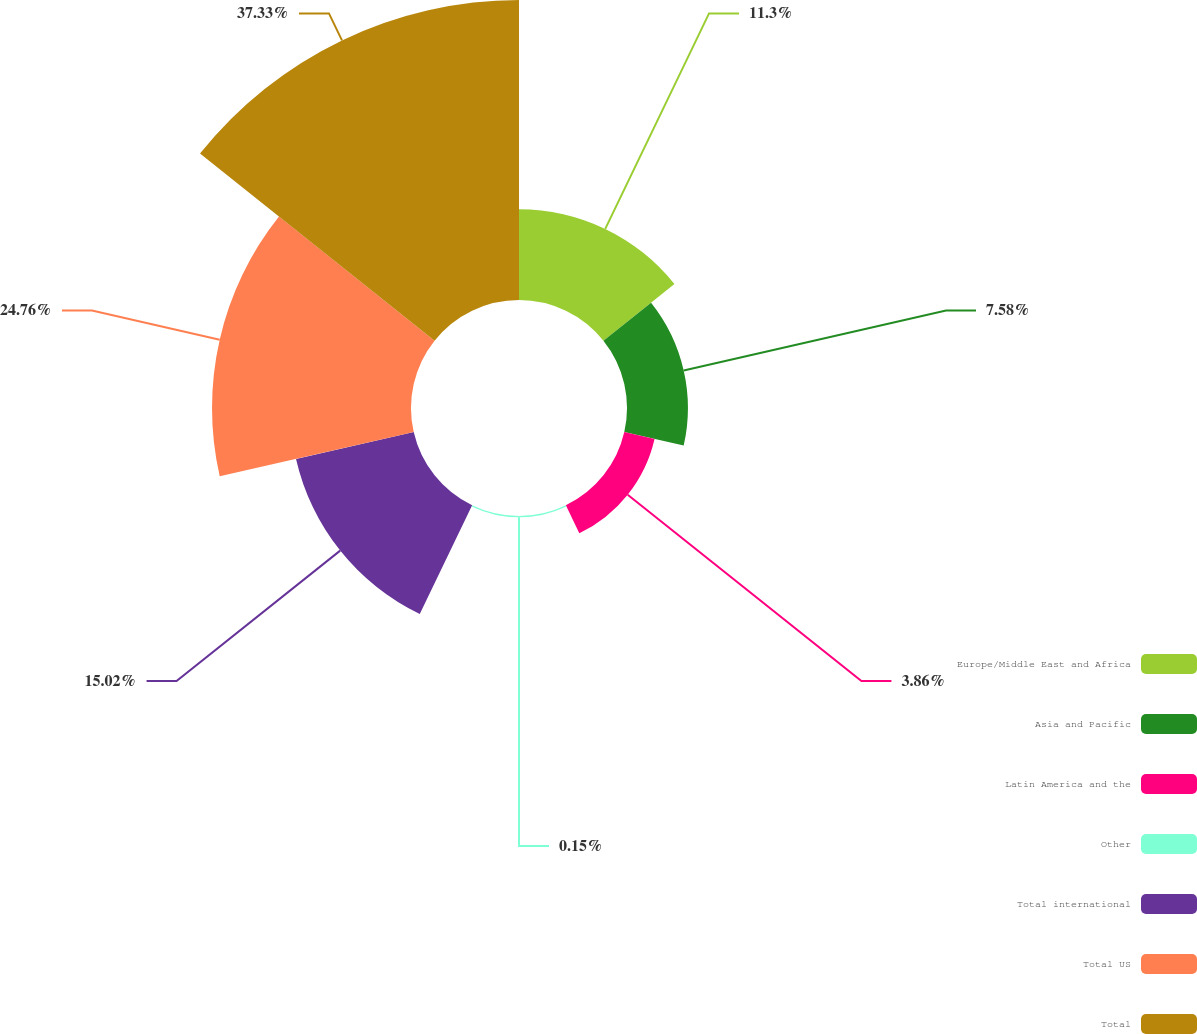Convert chart. <chart><loc_0><loc_0><loc_500><loc_500><pie_chart><fcel>Europe/Middle East and Africa<fcel>Asia and Pacific<fcel>Latin America and the<fcel>Other<fcel>Total international<fcel>Total US<fcel>Total<nl><fcel>11.3%<fcel>7.58%<fcel>3.86%<fcel>0.15%<fcel>15.02%<fcel>24.76%<fcel>37.33%<nl></chart> 